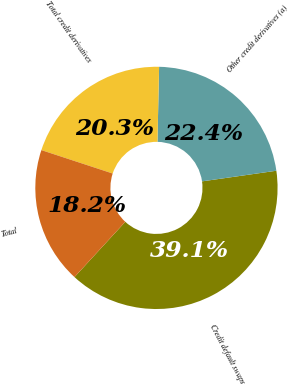Convert chart to OTSL. <chart><loc_0><loc_0><loc_500><loc_500><pie_chart><fcel>Credit default swaps<fcel>Other credit derivatives (a)<fcel>Total credit derivatives<fcel>Total<nl><fcel>39.09%<fcel>22.39%<fcel>20.3%<fcel>18.22%<nl></chart> 